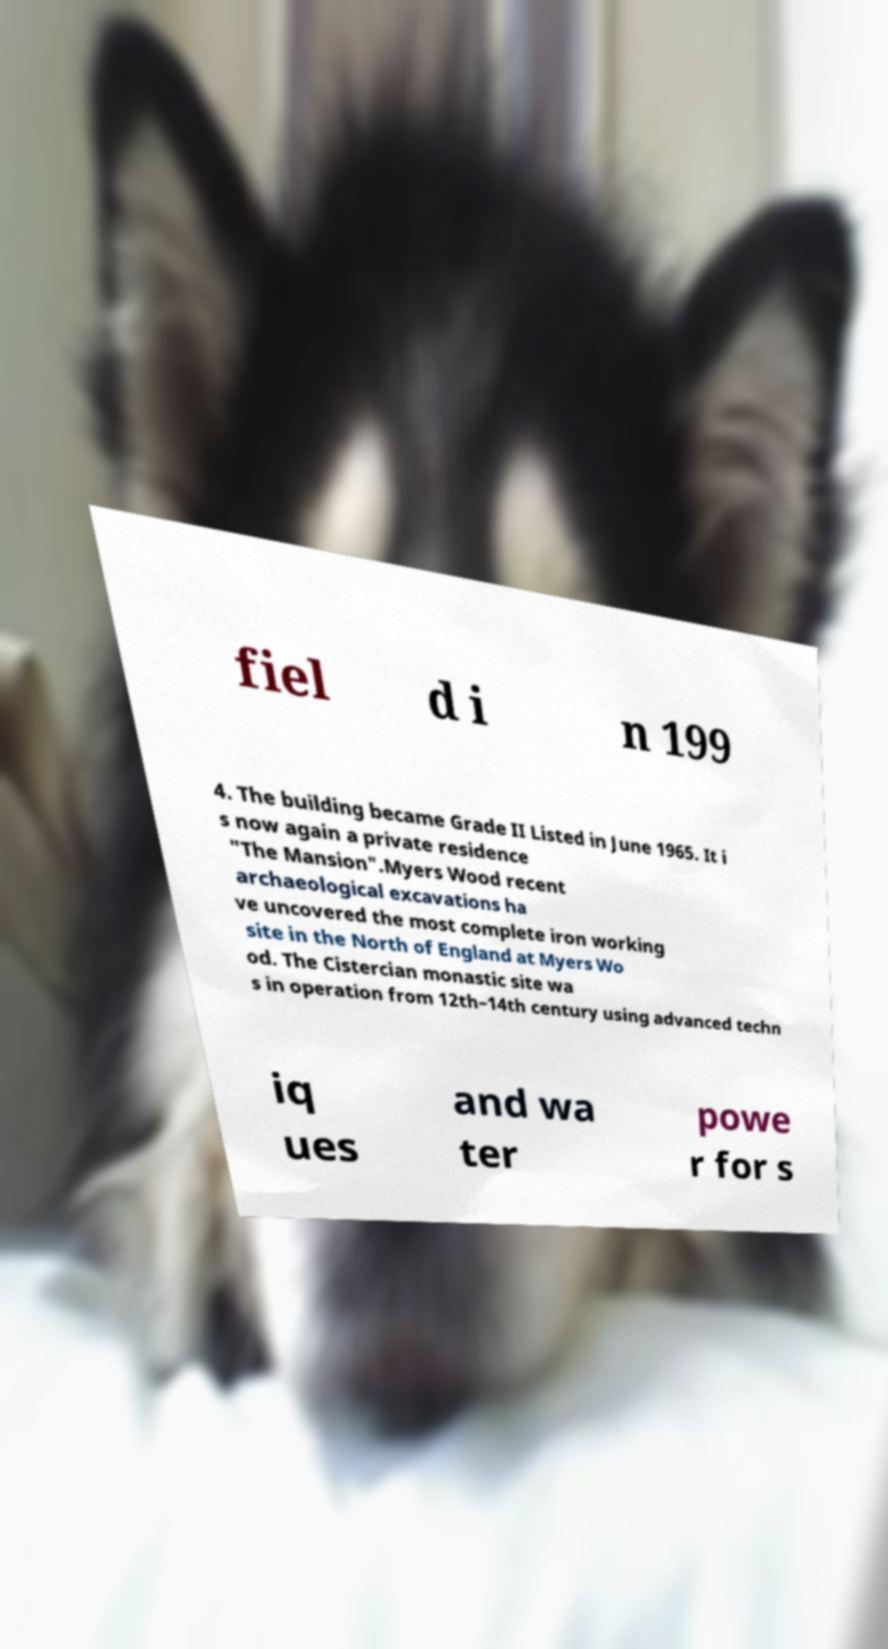There's text embedded in this image that I need extracted. Can you transcribe it verbatim? fiel d i n 199 4. The building became Grade II Listed in June 1965. It i s now again a private residence "The Mansion".Myers Wood recent archaeological excavations ha ve uncovered the most complete iron working site in the North of England at Myers Wo od. The Cistercian monastic site wa s in operation from 12th–14th century using advanced techn iq ues and wa ter powe r for s 